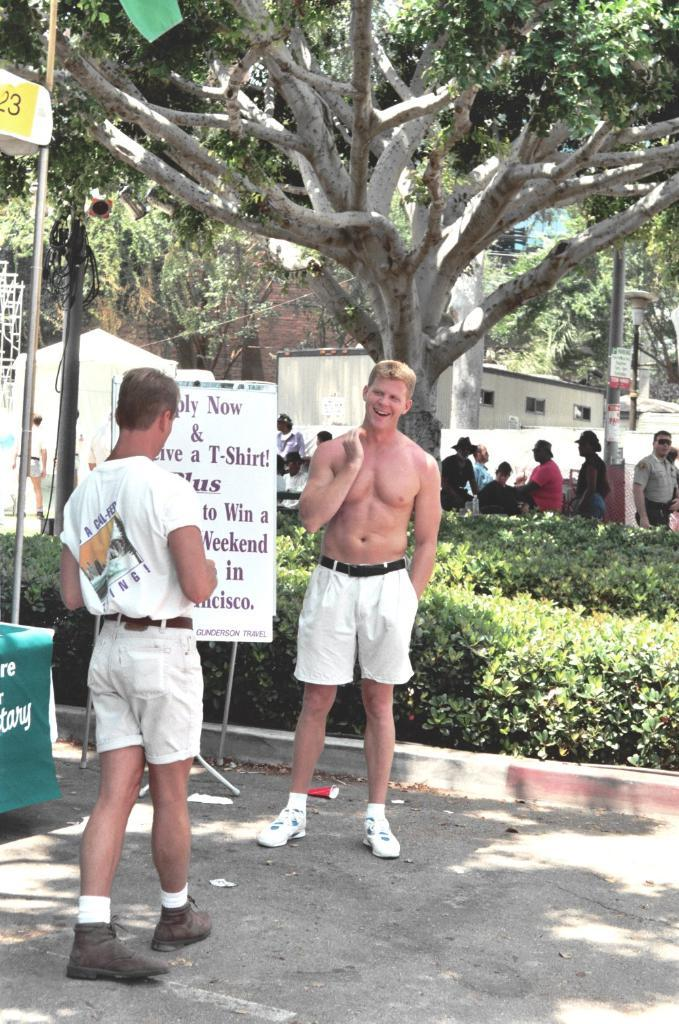<image>
Relay a brief, clear account of the picture shown. A shirtless man is standing next to a sign promoting a contest to win a weekend in San Francisco. 